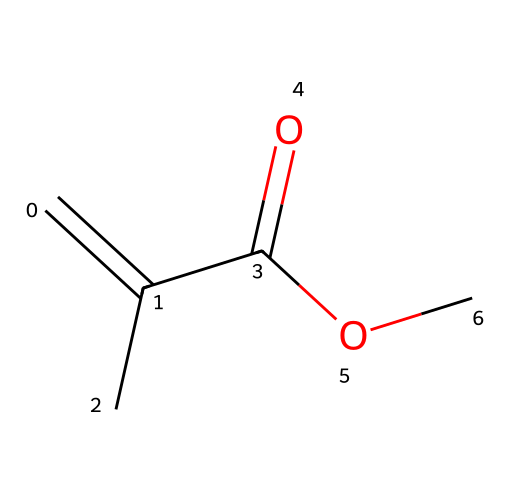What is the chemical name of this compound? The SMILES representation "C=C(C)C(=O)OC" corresponds to methyl methacrylate, which is derived from methacrylic acid and an alcohol.
Answer: methyl methacrylate How many carbon atoms are in the structure? Breaking down the SMILES "C=C(C)C(=O)OC", we identify four carbon atoms: three carbons in the backbone (C=C(C) part) and one additional from the methoxy group (OC).
Answer: four What type of functional group is present in methyl methacrylate? The structure contains a carbonyl group (C=O) and an ester functional group due to the presence of the OC part. This indicates it is an ester.
Answer: ester What is the hybridization of the carbon atom in the C=C bond? The carbon atoms involved in the double bond (C=C) are sp2 hybridized since they form both a double bond and two single bonds with other atoms.
Answer: sp2 Does this structure contain any oxygen atoms? The SMILES "C=C(C)C(=O)OC" reveals two oxygen atoms present, one in the carbonyl (C=O) and one in the methoxy (OC) group.
Answer: yes What type of isomerism can occur with methyl methacrylate? Methyl methacrylate can exhibit geometric (cis/trans) isomerism due to the presence of a double bond between the carbon atoms (C=C), influencing its spatial arrangement.
Answer: geometric isomerism 